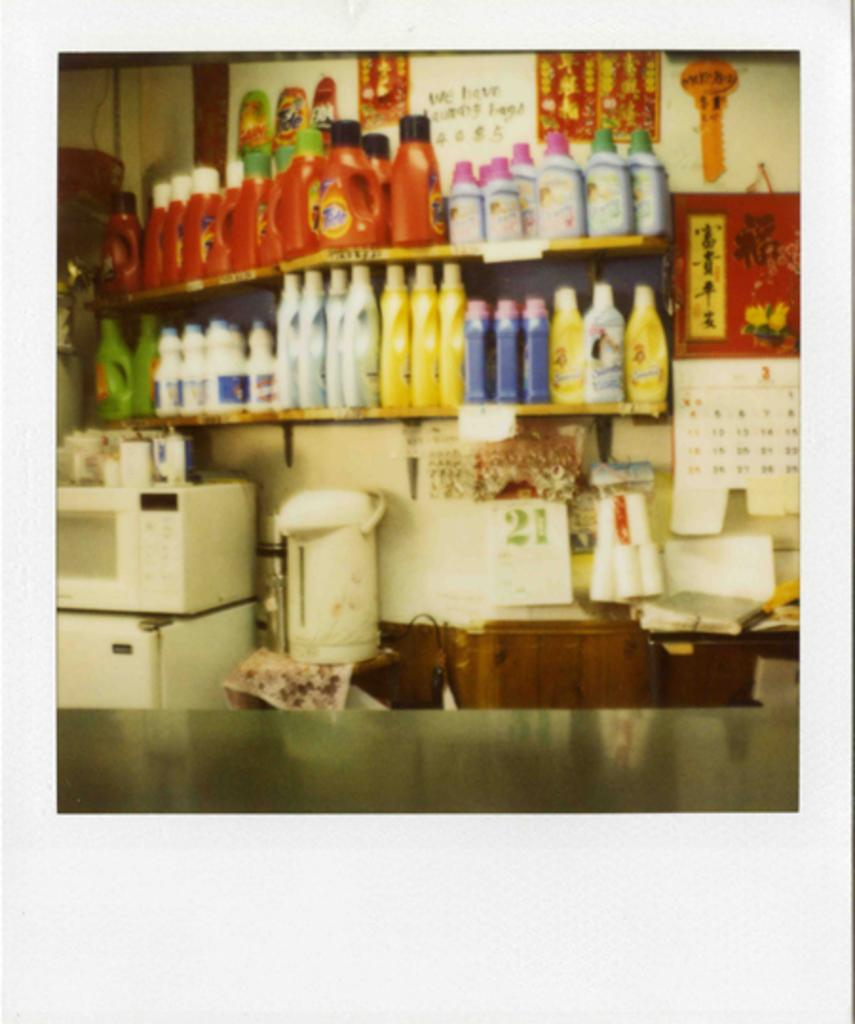Provide a one-sentence caption for the provided image. Grocery store with many items including Tide detergent. 